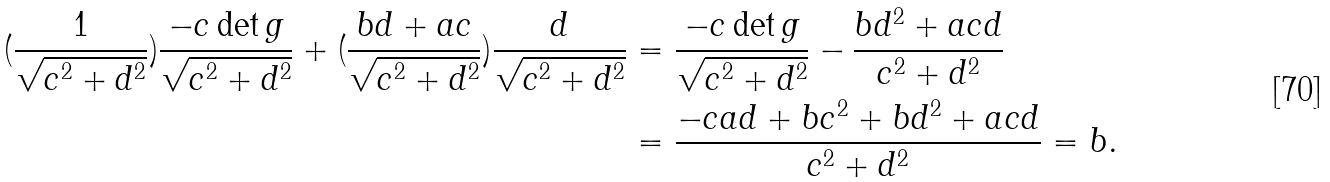Convert formula to latex. <formula><loc_0><loc_0><loc_500><loc_500>( \frac { 1 } { \sqrt { c ^ { 2 } + d ^ { 2 } } } ) \frac { - c \det g } { \sqrt { c ^ { 2 } + d ^ { 2 } } } + ( \frac { b d + a c } { \sqrt { c ^ { 2 } + d ^ { 2 } } } ) \frac { d } { \sqrt { c ^ { 2 } + d ^ { 2 } } } & = \frac { - c \det g } { \sqrt { c ^ { 2 } + d ^ { 2 } } } - \frac { b d ^ { 2 } + a c d } { c ^ { 2 } + d ^ { 2 } } \\ & = \frac { - c a d + b c ^ { 2 } + b d ^ { 2 } + a c d } { c ^ { 2 } + d ^ { 2 } } = b .</formula> 